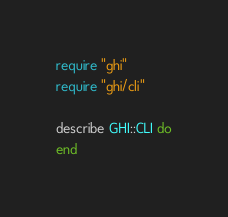<code> <loc_0><loc_0><loc_500><loc_500><_Ruby_>require "ghi"
require "ghi/cli"

describe GHI::CLI do
end
</code> 